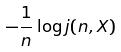<formula> <loc_0><loc_0><loc_500><loc_500>- \frac { 1 } { n } \log j ( n , X )</formula> 